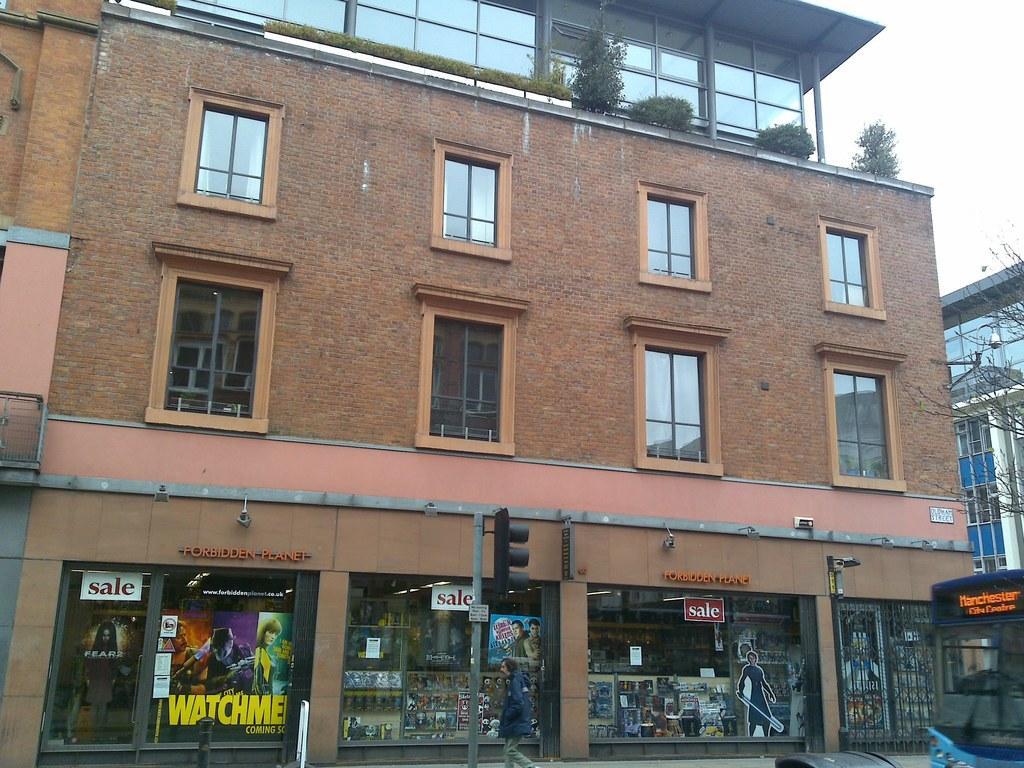In one or two sentences, can you explain what this image depicts? In this image in the center there is a building and on the top of the building there are plants and there are glasses at the bottom of the building with some text written on it and in front of the building there are poles, there is a man walking. On the right side there is a building and there are trees and there is a bus and the sky is cloudy. 